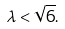Convert formula to latex. <formula><loc_0><loc_0><loc_500><loc_500>\lambda < \sqrt { 6 } .</formula> 